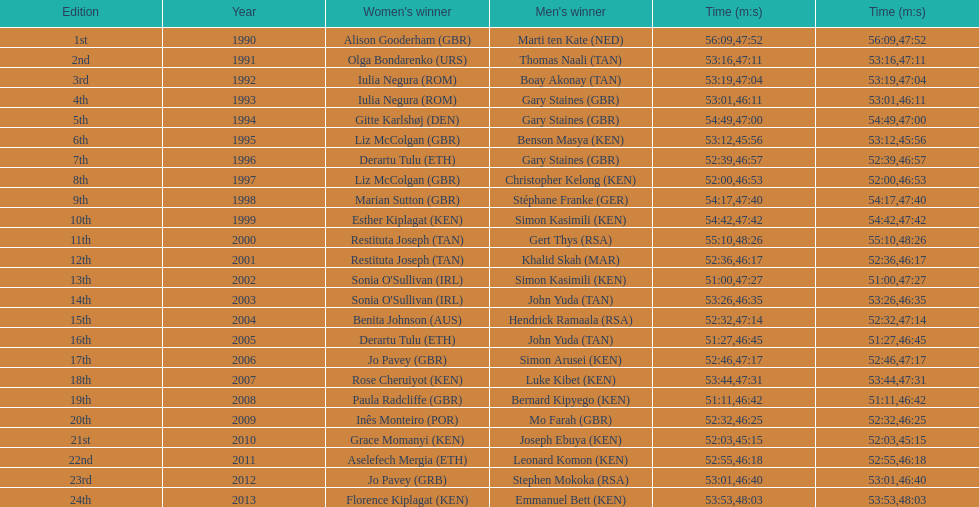What is the difference in finishing times for the men's and women's bupa great south run finish for 2013? 5:50. 